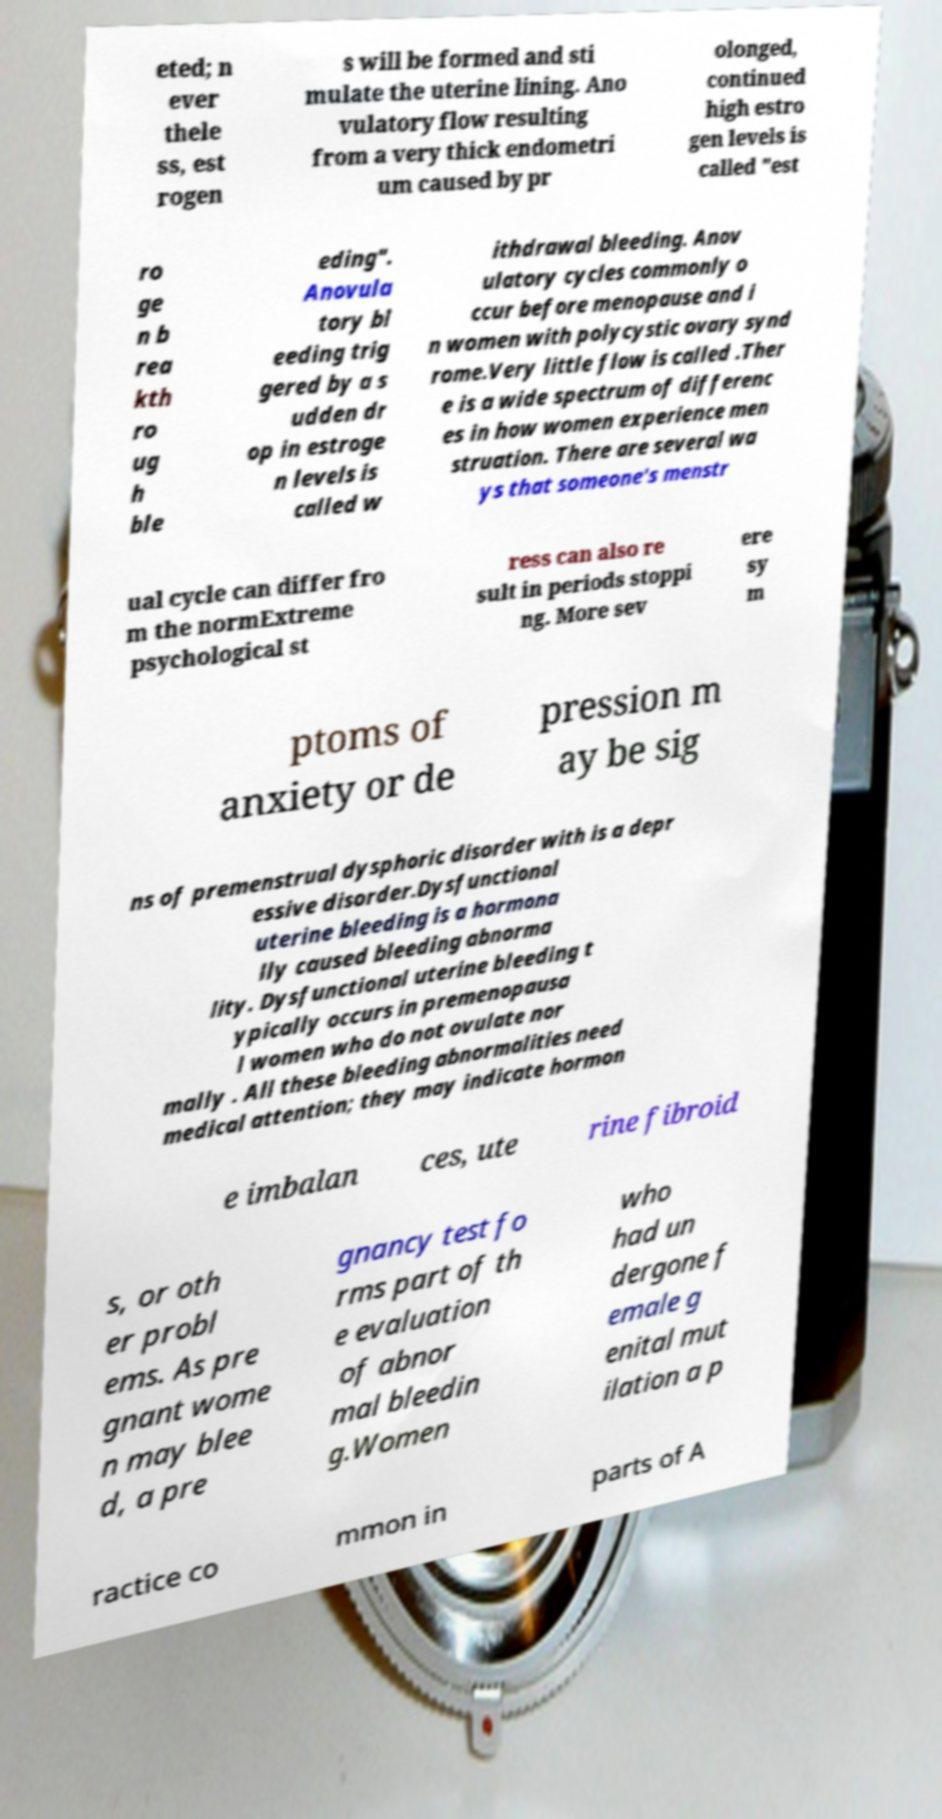I need the written content from this picture converted into text. Can you do that? eted; n ever thele ss, est rogen s will be formed and sti mulate the uterine lining. Ano vulatory flow resulting from a very thick endometri um caused by pr olonged, continued high estro gen levels is called "est ro ge n b rea kth ro ug h ble eding". Anovula tory bl eeding trig gered by a s udden dr op in estroge n levels is called w ithdrawal bleeding. Anov ulatory cycles commonly o ccur before menopause and i n women with polycystic ovary synd rome.Very little flow is called .Ther e is a wide spectrum of differenc es in how women experience men struation. There are several wa ys that someone's menstr ual cycle can differ fro m the normExtreme psychological st ress can also re sult in periods stoppi ng. More sev ere sy m ptoms of anxiety or de pression m ay be sig ns of premenstrual dysphoric disorder with is a depr essive disorder.Dysfunctional uterine bleeding is a hormona lly caused bleeding abnorma lity. Dysfunctional uterine bleeding t ypically occurs in premenopausa l women who do not ovulate nor mally . All these bleeding abnormalities need medical attention; they may indicate hormon e imbalan ces, ute rine fibroid s, or oth er probl ems. As pre gnant wome n may blee d, a pre gnancy test fo rms part of th e evaluation of abnor mal bleedin g.Women who had un dergone f emale g enital mut ilation a p ractice co mmon in parts of A 